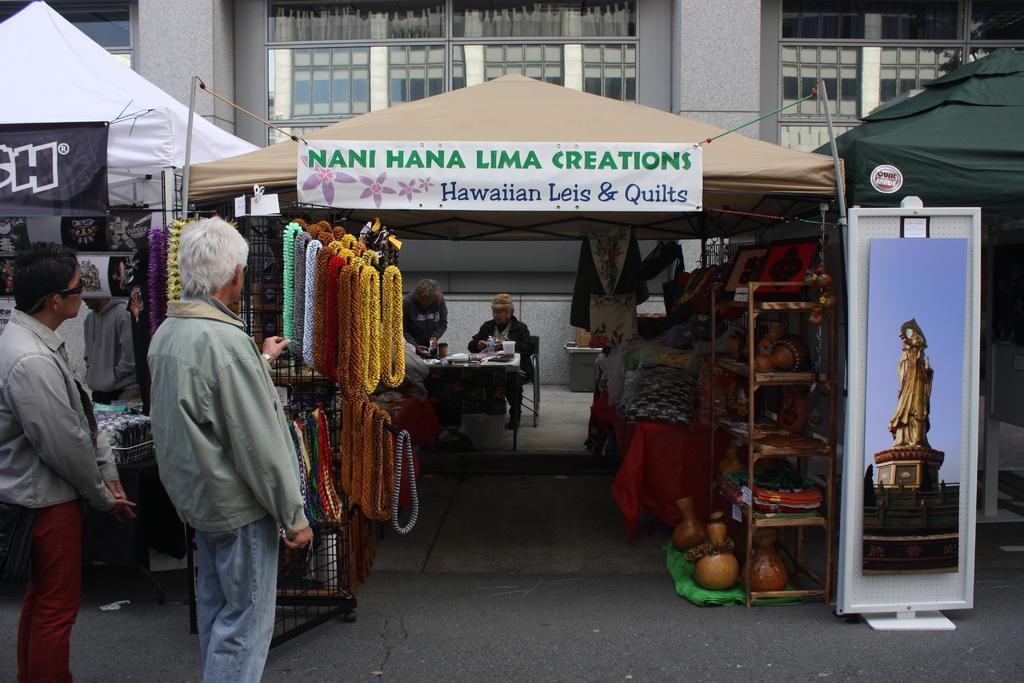Could you give a brief overview of what you see in this image? In this image, we can see few stalls, banners. Here we can see some objects, grill, few things. At the bottom, there is a road. Here we can see few people. Few are standing. Here a person is sitting on the chair. Background there is a house, glass windows, curtains. 